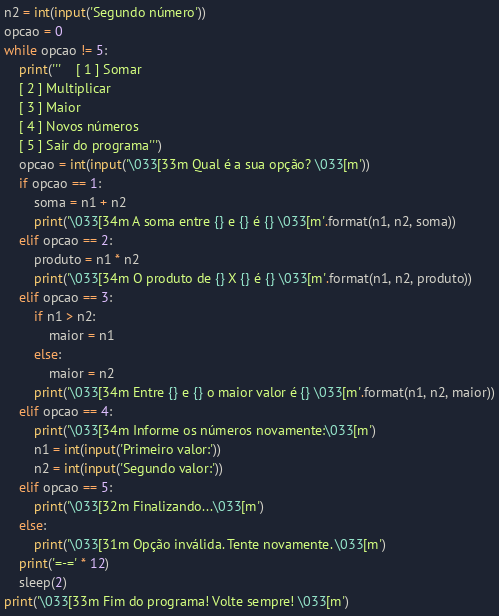Convert code to text. <code><loc_0><loc_0><loc_500><loc_500><_Python_>n2 = int(input('Segundo número'))
opcao = 0
while opcao != 5:
    print('''    [ 1 ] Somar
    [ 2 ] Multiplicar
    [ 3 ] Maior
    [ 4 ] Novos números
    [ 5 ] Sair do programa''')
    opcao = int(input('\033[33m Qual é a sua opção? \033[m'))
    if opcao == 1:
        soma = n1 + n2
        print('\033[34m A soma entre {} e {} é {} \033[m'.format(n1, n2, soma))
    elif opcao == 2:
        produto = n1 * n2
        print('\033[34m O produto de {} X {} é {} \033[m'.format(n1, n2, produto))
    elif opcao == 3:
        if n1 > n2:
            maior = n1
        else:
            maior = n2
        print('\033[34m Entre {} e {} o maior valor é {} \033[m'.format(n1, n2, maior))
    elif opcao == 4:
        print('\033[34m Informe os números novamente:\033[m')
        n1 = int(input('Primeiro valor:'))
        n2 = int(input('Segundo valor:'))
    elif opcao == 5:
        print('\033[32m Finalizando...\033[m')
    else:
        print('\033[31m Opção inválida. Tente novamente. \033[m')
    print('=-=' * 12)
    sleep(2)
print('\033[33m Fim do programa! Volte sempre! \033[m')




</code> 